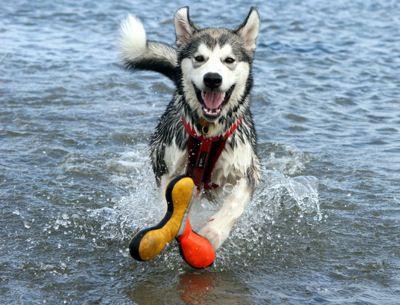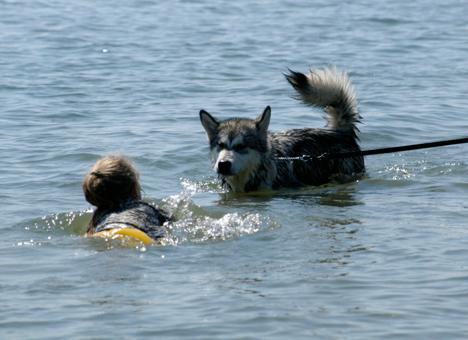The first image is the image on the left, the second image is the image on the right. Given the left and right images, does the statement "All of the dogs are in the water." hold true? Answer yes or no. Yes. The first image is the image on the left, the second image is the image on the right. For the images shown, is this caption "Each image shows a dog in the water, with one of the dog's pictured facing directly forward and wearing a red collar." true? Answer yes or no. Yes. 